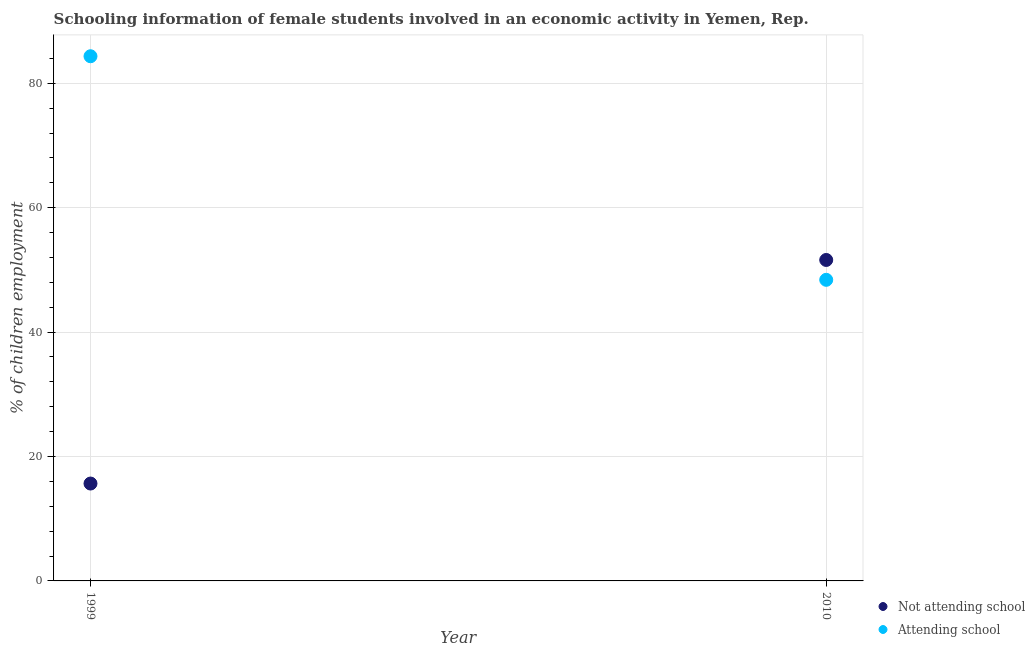How many different coloured dotlines are there?
Provide a succinct answer. 2. Is the number of dotlines equal to the number of legend labels?
Make the answer very short. Yes. What is the percentage of employed females who are attending school in 2010?
Your response must be concise. 48.4. Across all years, what is the maximum percentage of employed females who are attending school?
Your answer should be very brief. 84.34. Across all years, what is the minimum percentage of employed females who are attending school?
Your answer should be very brief. 48.4. In which year was the percentage of employed females who are not attending school maximum?
Provide a succinct answer. 2010. What is the total percentage of employed females who are attending school in the graph?
Ensure brevity in your answer.  132.75. What is the difference between the percentage of employed females who are attending school in 1999 and that in 2010?
Ensure brevity in your answer.  35.94. What is the difference between the percentage of employed females who are not attending school in 2010 and the percentage of employed females who are attending school in 1999?
Offer a very short reply. -32.75. What is the average percentage of employed females who are not attending school per year?
Offer a very short reply. 33.63. In the year 1999, what is the difference between the percentage of employed females who are not attending school and percentage of employed females who are attending school?
Your answer should be compact. -68.69. What is the ratio of the percentage of employed females who are attending school in 1999 to that in 2010?
Provide a short and direct response. 1.74. Is the percentage of employed females who are not attending school in 1999 less than that in 2010?
Make the answer very short. Yes. In how many years, is the percentage of employed females who are attending school greater than the average percentage of employed females who are attending school taken over all years?
Offer a terse response. 1. Does the percentage of employed females who are not attending school monotonically increase over the years?
Provide a short and direct response. Yes. Is the percentage of employed females who are attending school strictly less than the percentage of employed females who are not attending school over the years?
Ensure brevity in your answer.  No. How many years are there in the graph?
Offer a very short reply. 2. What is the difference between two consecutive major ticks on the Y-axis?
Offer a terse response. 20. Does the graph contain any zero values?
Provide a succinct answer. No. Does the graph contain grids?
Your answer should be compact. Yes. How many legend labels are there?
Make the answer very short. 2. How are the legend labels stacked?
Provide a short and direct response. Vertical. What is the title of the graph?
Your answer should be compact. Schooling information of female students involved in an economic activity in Yemen, Rep. What is the label or title of the Y-axis?
Make the answer very short. % of children employment. What is the % of children employment in Not attending school in 1999?
Your response must be concise. 15.66. What is the % of children employment of Attending school in 1999?
Keep it short and to the point. 84.34. What is the % of children employment of Not attending school in 2010?
Make the answer very short. 51.6. What is the % of children employment in Attending school in 2010?
Your response must be concise. 48.4. Across all years, what is the maximum % of children employment of Not attending school?
Provide a succinct answer. 51.6. Across all years, what is the maximum % of children employment in Attending school?
Make the answer very short. 84.34. Across all years, what is the minimum % of children employment of Not attending school?
Provide a succinct answer. 15.66. Across all years, what is the minimum % of children employment in Attending school?
Ensure brevity in your answer.  48.4. What is the total % of children employment in Not attending school in the graph?
Your answer should be very brief. 67.25. What is the total % of children employment in Attending school in the graph?
Offer a terse response. 132.75. What is the difference between the % of children employment of Not attending school in 1999 and that in 2010?
Ensure brevity in your answer.  -35.94. What is the difference between the % of children employment of Attending school in 1999 and that in 2010?
Offer a terse response. 35.94. What is the difference between the % of children employment of Not attending school in 1999 and the % of children employment of Attending school in 2010?
Make the answer very short. -32.75. What is the average % of children employment in Not attending school per year?
Give a very brief answer. 33.63. What is the average % of children employment of Attending school per year?
Your response must be concise. 66.37. In the year 1999, what is the difference between the % of children employment in Not attending school and % of children employment in Attending school?
Make the answer very short. -68.69. In the year 2010, what is the difference between the % of children employment of Not attending school and % of children employment of Attending school?
Make the answer very short. 3.19. What is the ratio of the % of children employment of Not attending school in 1999 to that in 2010?
Ensure brevity in your answer.  0.3. What is the ratio of the % of children employment of Attending school in 1999 to that in 2010?
Ensure brevity in your answer.  1.74. What is the difference between the highest and the second highest % of children employment of Not attending school?
Provide a short and direct response. 35.94. What is the difference between the highest and the second highest % of children employment in Attending school?
Provide a succinct answer. 35.94. What is the difference between the highest and the lowest % of children employment of Not attending school?
Your answer should be very brief. 35.94. What is the difference between the highest and the lowest % of children employment in Attending school?
Give a very brief answer. 35.94. 